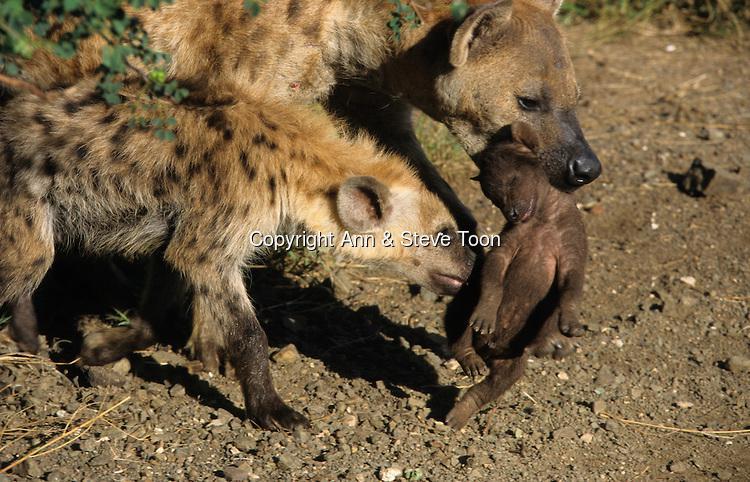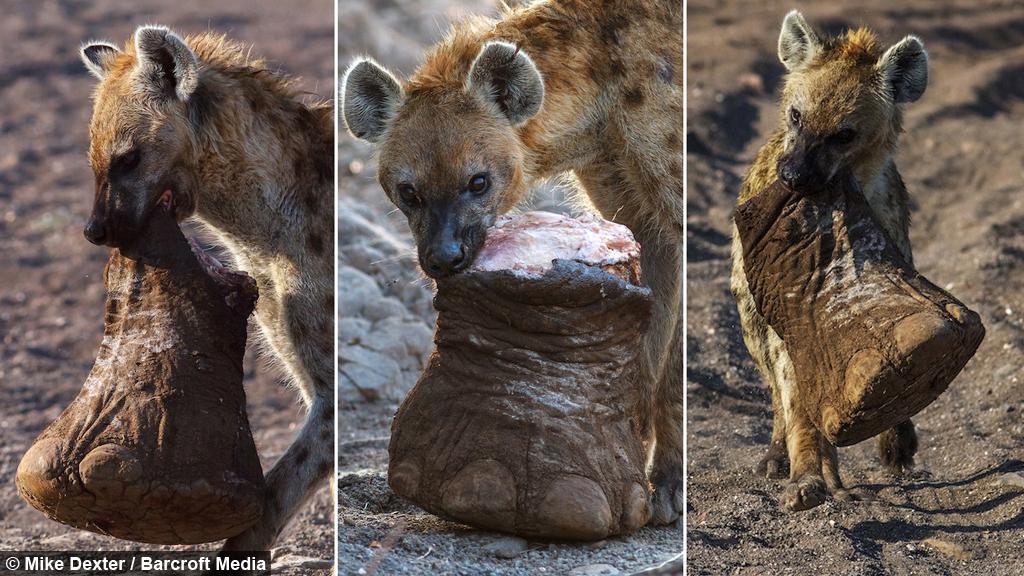The first image is the image on the left, the second image is the image on the right. Evaluate the accuracy of this statement regarding the images: "Each image shows one adult hyena carrying at least one pup in its mouth.". Is it true? Answer yes or no. No. 